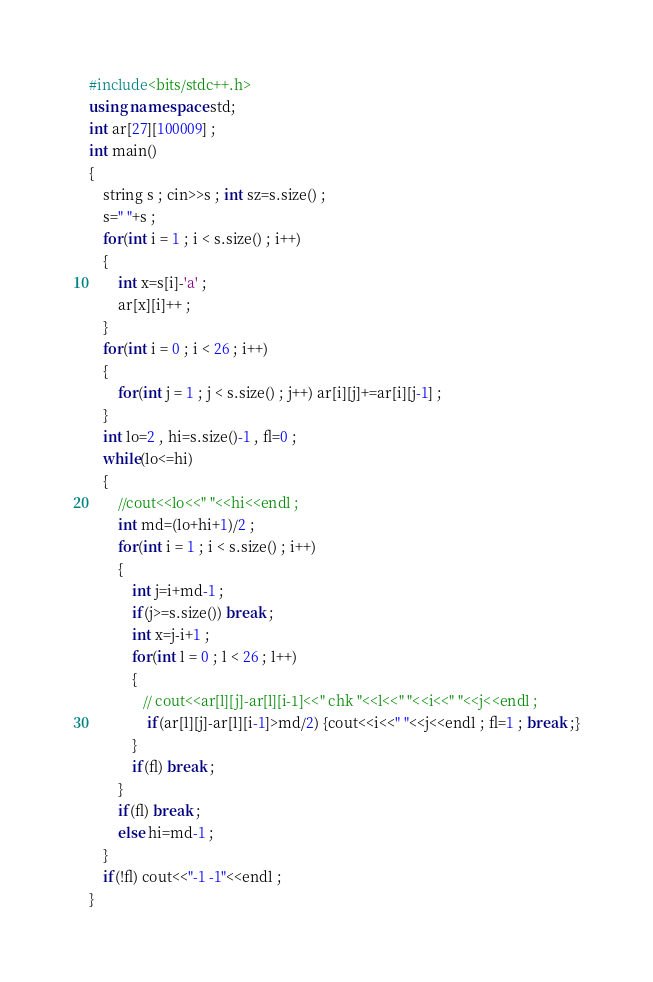Convert code to text. <code><loc_0><loc_0><loc_500><loc_500><_C++_>#include<bits/stdc++.h>
using namespace std;
int ar[27][100009] ;
int main()
{
    string s ; cin>>s ; int sz=s.size() ;
    s=" "+s ;
    for(int i = 1 ; i < s.size() ; i++)
    {
        int x=s[i]-'a' ;
        ar[x][i]++ ;
    }
    for(int i = 0 ; i < 26 ; i++)
    {
        for(int j = 1 ; j < s.size() ; j++) ar[i][j]+=ar[i][j-1] ;
    }
    int lo=2 , hi=s.size()-1 , fl=0 ;
    while(lo<=hi)
    {
        //cout<<lo<<" "<<hi<<endl ;
        int md=(lo+hi+1)/2 ;
        for(int i = 1 ; i < s.size() ; i++)
        {
            int j=i+md-1 ;
            if(j>=s.size()) break ;
            int x=j-i+1 ;
            for(int l = 0 ; l < 26 ; l++)
            {
               // cout<<ar[l][j]-ar[l][i-1]<<" chk "<<l<<" "<<i<<" "<<j<<endl ;
                if(ar[l][j]-ar[l][i-1]>md/2) {cout<<i<<" "<<j<<endl ; fl=1 ; break ;}
            }
            if(fl) break ;
        }
        if(fl) break ;
        else hi=md-1 ;
    }
    if(!fl) cout<<"-1 -1"<<endl ;
}
</code> 